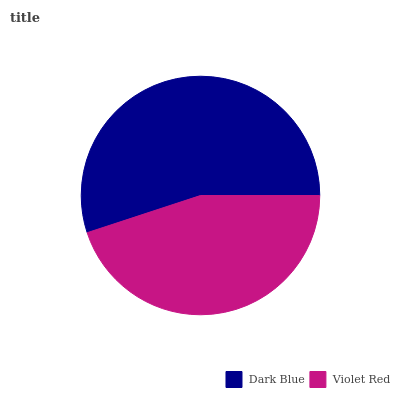Is Violet Red the minimum?
Answer yes or no. Yes. Is Dark Blue the maximum?
Answer yes or no. Yes. Is Violet Red the maximum?
Answer yes or no. No. Is Dark Blue greater than Violet Red?
Answer yes or no. Yes. Is Violet Red less than Dark Blue?
Answer yes or no. Yes. Is Violet Red greater than Dark Blue?
Answer yes or no. No. Is Dark Blue less than Violet Red?
Answer yes or no. No. Is Dark Blue the high median?
Answer yes or no. Yes. Is Violet Red the low median?
Answer yes or no. Yes. Is Violet Red the high median?
Answer yes or no. No. Is Dark Blue the low median?
Answer yes or no. No. 